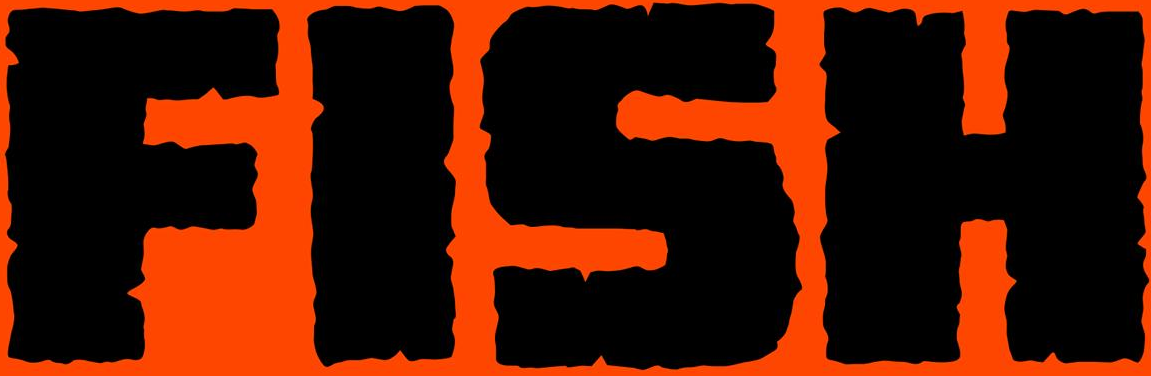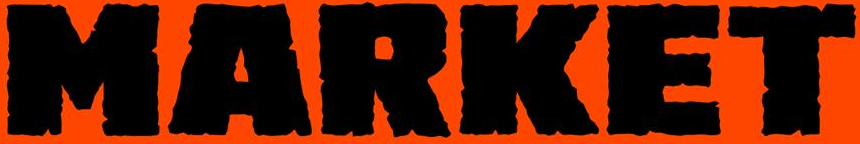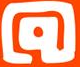Read the text from these images in sequence, separated by a semicolon. FISH; MARKET; @ 